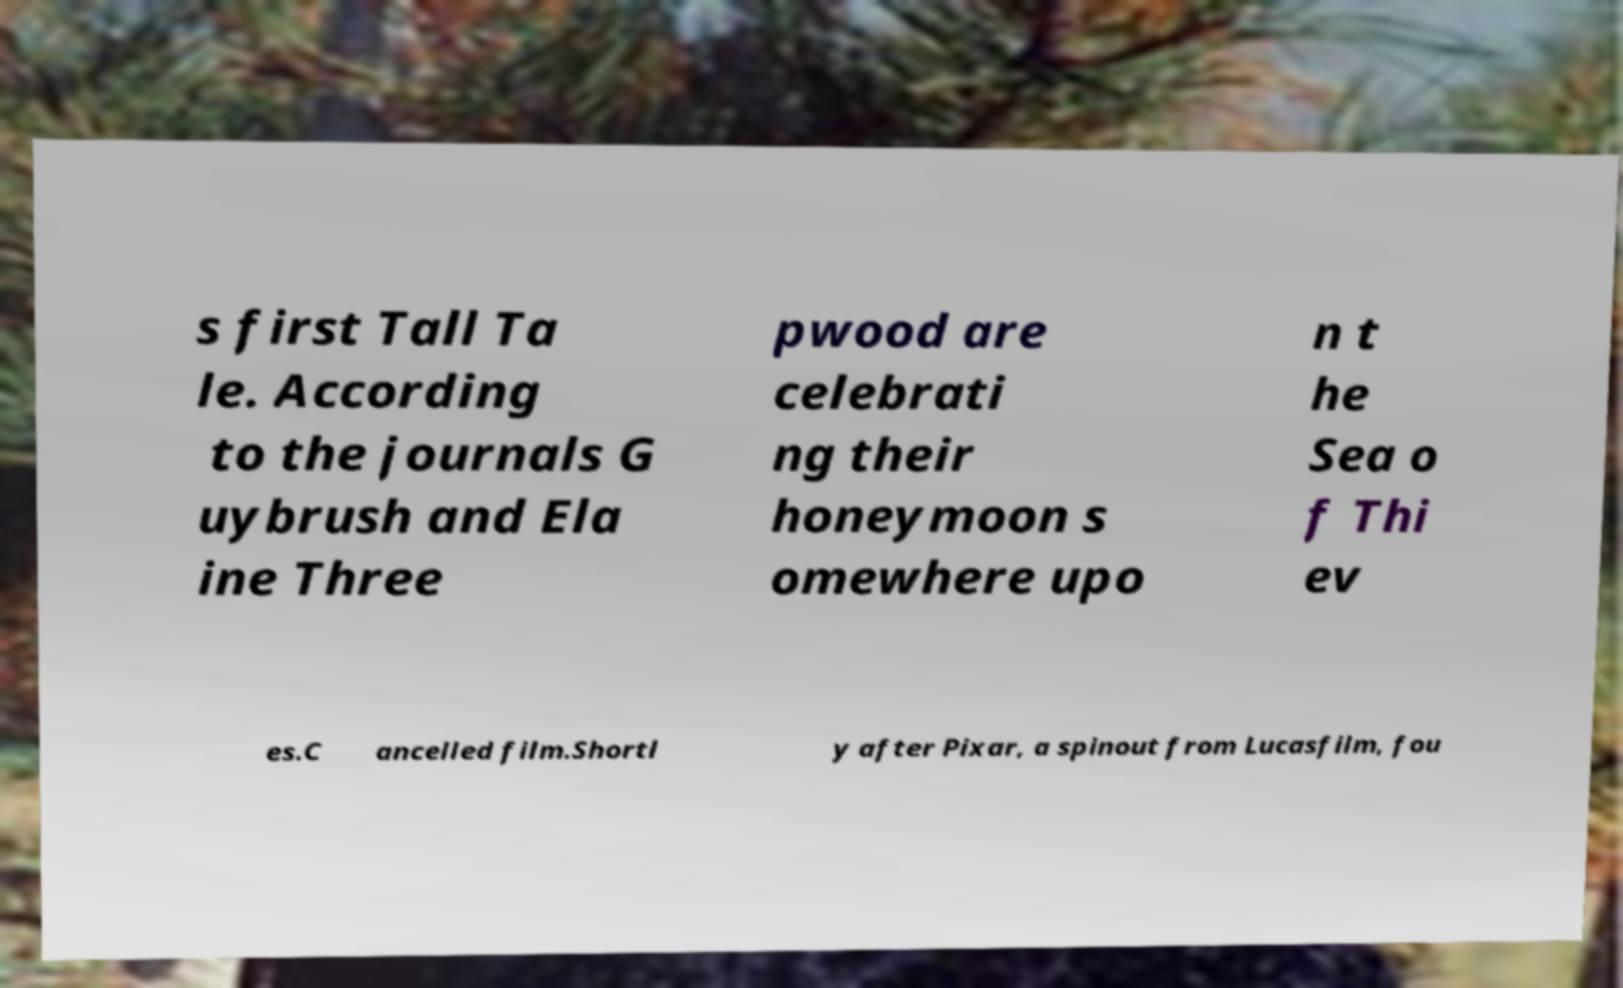What messages or text are displayed in this image? I need them in a readable, typed format. s first Tall Ta le. According to the journals G uybrush and Ela ine Three pwood are celebrati ng their honeymoon s omewhere upo n t he Sea o f Thi ev es.C ancelled film.Shortl y after Pixar, a spinout from Lucasfilm, fou 